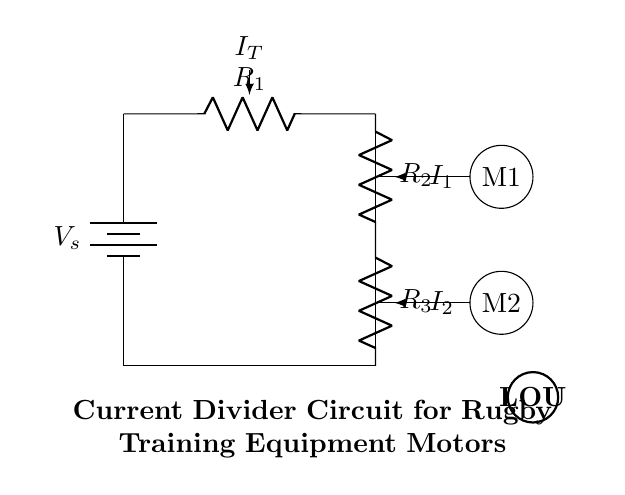What is the main voltage source in this circuit? The main voltage source is labeled as Vs, which is the battery providing the necessary voltage for the circuit operation.
Answer: Vs What are the resistances used in the current divider? The resistances in the circuit are R1, R2, and R3, as indicated by the labels on each resistor in the diagram.
Answer: R1, R2, R3 How many motors are connected to the current divider circuit? Two motors are connected to the current divider circuit, M1 and M2, as indicated by the motor symbols shown in the diagram.
Answer: 2 What is the current entering the circuit labeled as? The current entering the circuit is labeled as It, indicating the total current flowing from the voltage source into the circuit branches.
Answer: It What currents flow through the motors M1 and M2? The currents flowing through the motors are labeled as I1 for motor M1 and I2 for motor M2, representing the specific currents allocated to each motor from the current divider.
Answer: I1, I2 If R2 has a resistance of 6 ohms and R3 has a resistance of 12 ohms, what is the ratio of currents I2 to I1? In a current divider configuration, the ratio of the currents can be found using the formula I2/I1 = R1/(R2 + R3). Since R2 is 6 ohms and R3 is 12 ohms, the total resistance for I1 is 18 ohms. Thus, I2/I1 = 18/6 = 3.
Answer: 3 If the total current It is 30 mA, what is the current I1? Using the current divider formula and the previous ratio, we know I2 = It * (R3/(R2 + R3)). Plugging in the values gives I1 = It / (1 + R2/R3) = 30 mA / (1 + 6/12) = 20 mA.
Answer: 20 mA 